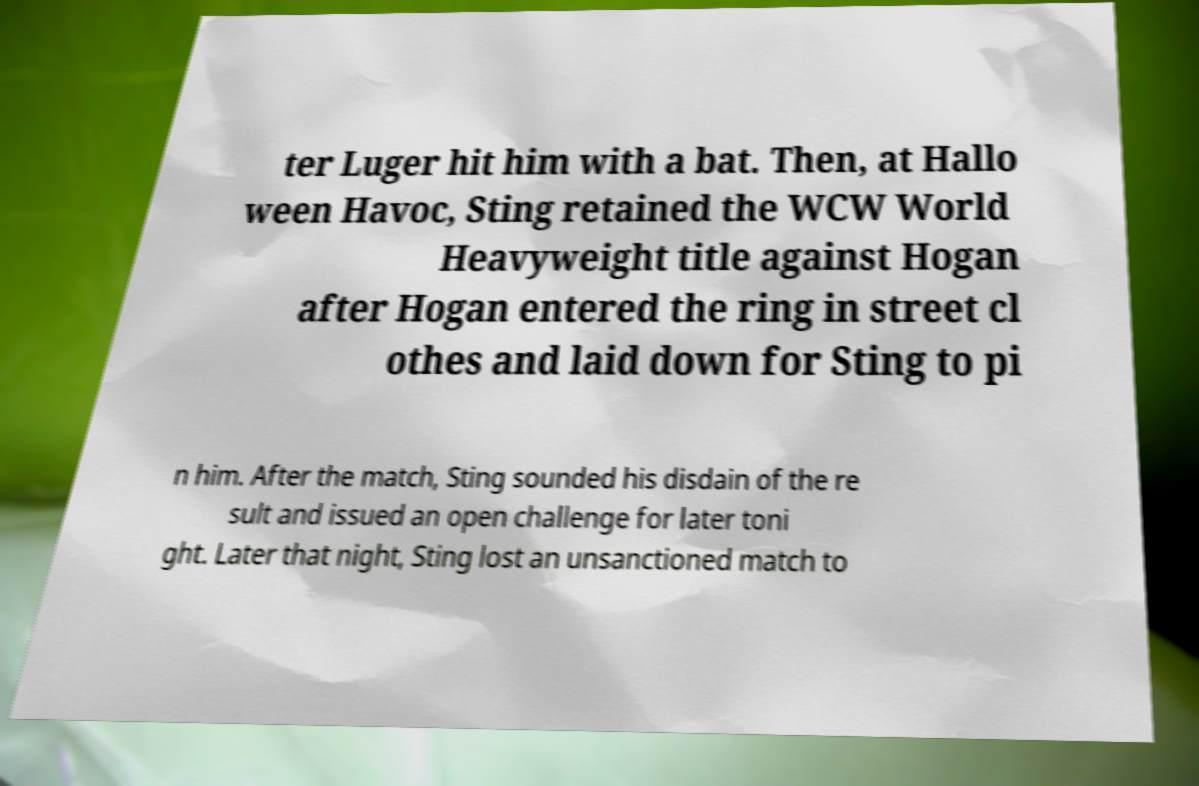Please read and relay the text visible in this image. What does it say? ter Luger hit him with a bat. Then, at Hallo ween Havoc, Sting retained the WCW World Heavyweight title against Hogan after Hogan entered the ring in street cl othes and laid down for Sting to pi n him. After the match, Sting sounded his disdain of the re sult and issued an open challenge for later toni ght. Later that night, Sting lost an unsanctioned match to 